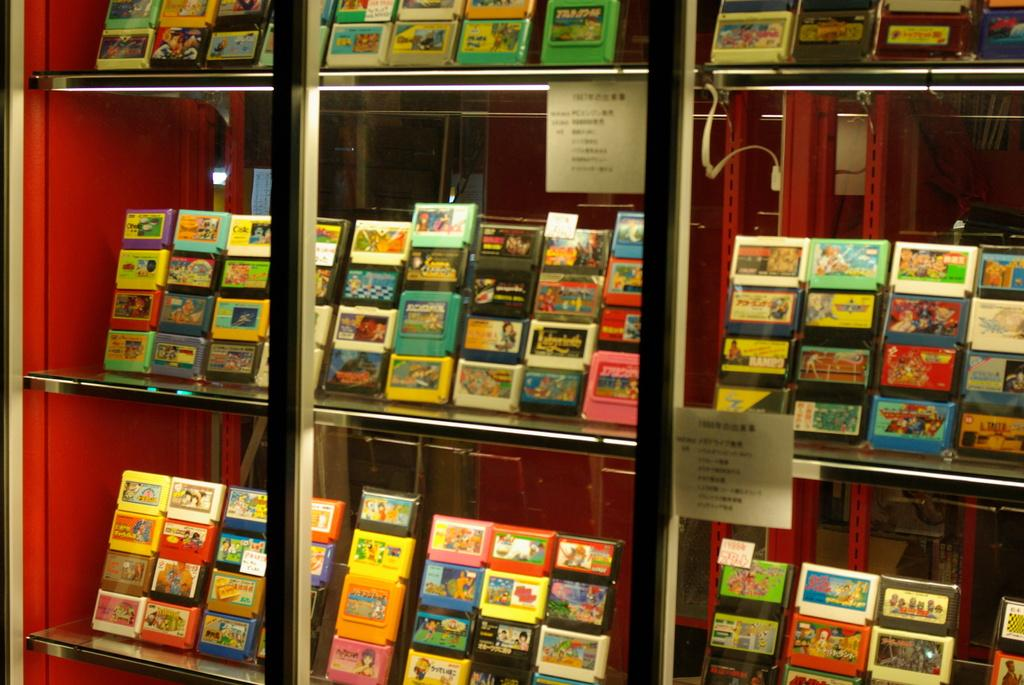What is the main subject of the image? The main subject of the image is a glass shelf with objects arranged on it. Can you describe the arrangement of the objects on the shelf? Unfortunately, the provided facts do not give enough information to describe the arrangement of the objects on the shelf. What type of objects can be seen on the shelf? The provided facts do not specify the type of objects on the shelf. What is the smell of the downtown area in the image? There is no downtown area present in the image, and therefore no smell can be associated with it. 